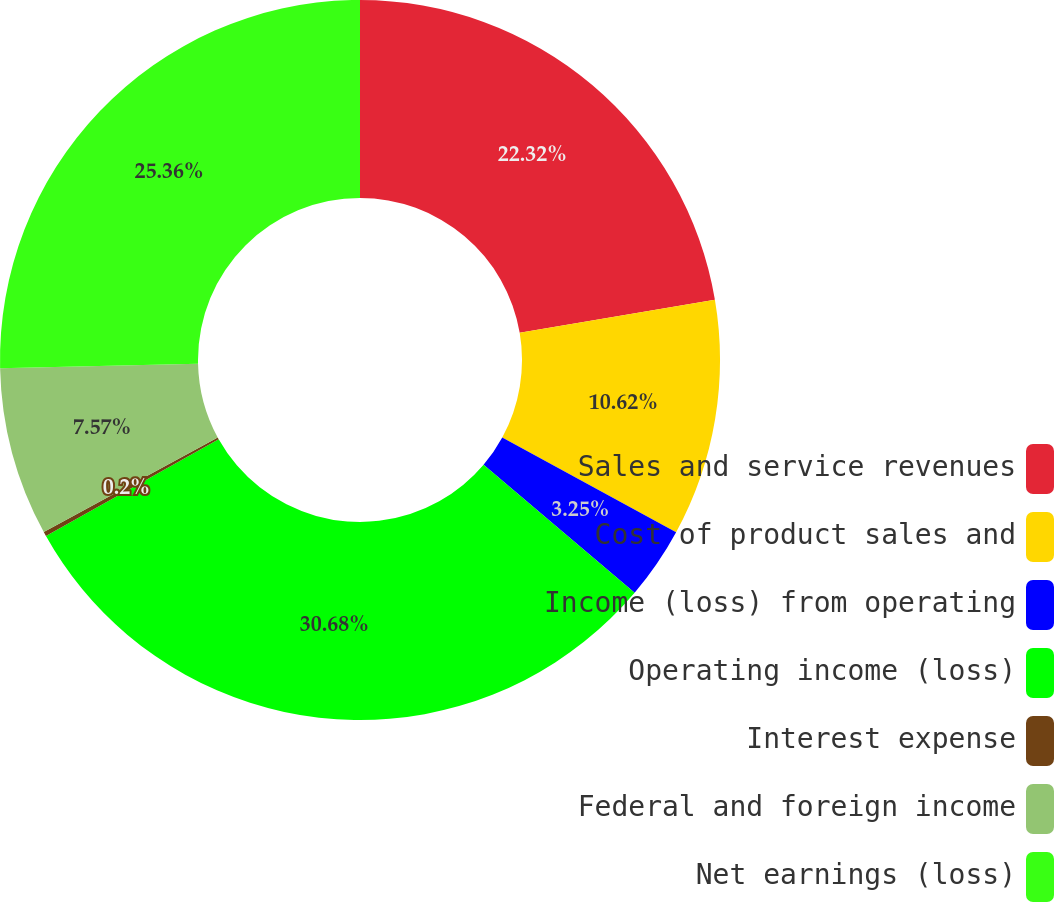<chart> <loc_0><loc_0><loc_500><loc_500><pie_chart><fcel>Sales and service revenues<fcel>Cost of product sales and<fcel>Income (loss) from operating<fcel>Operating income (loss)<fcel>Interest expense<fcel>Federal and foreign income<fcel>Net earnings (loss)<nl><fcel>22.32%<fcel>10.62%<fcel>3.25%<fcel>30.68%<fcel>0.2%<fcel>7.57%<fcel>25.36%<nl></chart> 